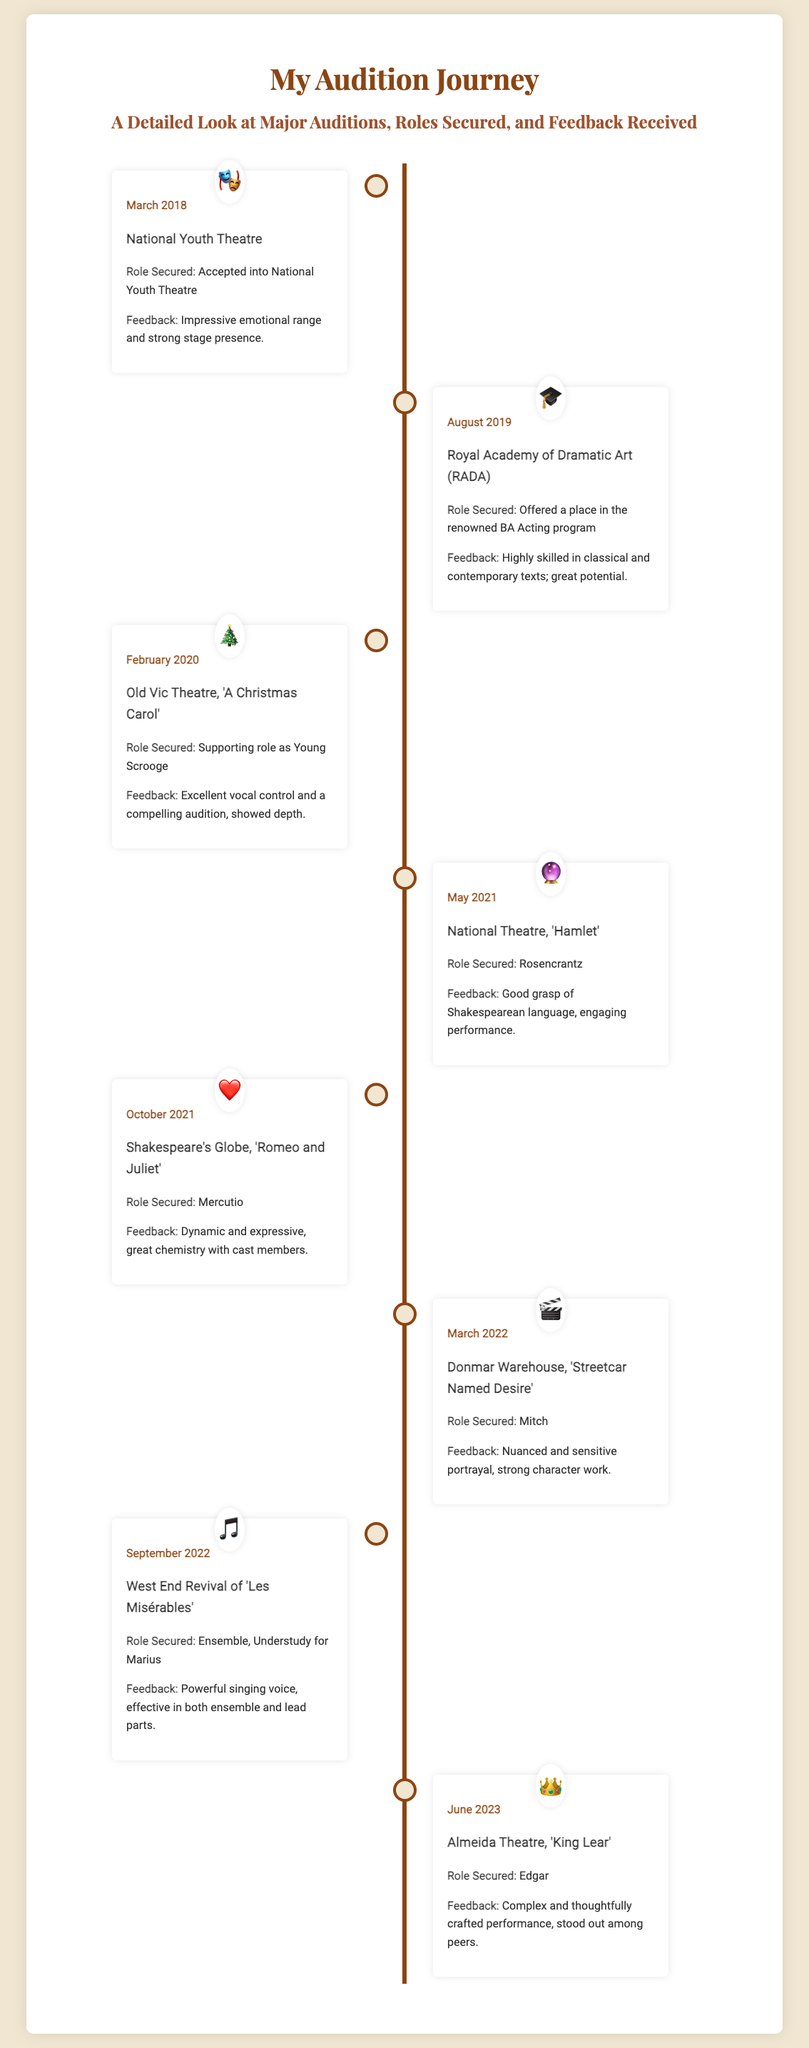What was the first role secured? The first role secured is noted in the March 2018 entry of the timeline, which was being accepted into the National Youth Theatre.
Answer: Accepted into National Youth Theatre What was the feedback received for the role of Young Scrooge? The feedback for the supporting role as Young Scrooge in February 2020 highlights excellent vocal control and a compelling audition.
Answer: Excellent vocal control and a compelling audition In what year did the audition for 'Hamlet' take place? The audition for 'Hamlet' occurred in May 2021, as indicated on the timeline.
Answer: 2021 Which role was performed at the Almeida Theatre? The role performed at the Almeida Theatre is specified in the June 2023 entry, which was Edgar.
Answer: Edgar What was the feedback after the audition for 'Romeo and Juliet'? The feedback following the audition for 'Romeo and Juliet' indicates a dynamic and expressive performance with great chemistry among cast members.
Answer: Dynamic and expressive, great chemistry with cast members How many roles are listed in the timeline? The timeline contains a total of eight entries detailing different roles secured.
Answer: Eight Which theatre was involved in the 'Les Misérables' revival? The theatre associated with the revival of 'Les Misérables' is mentioned in the September 2022 entry.
Answer: West End What is the icon that represents the National Youth Theatre? The icon representing the National Youth Theatre in the timeline is a mask.
Answer: 🎭 